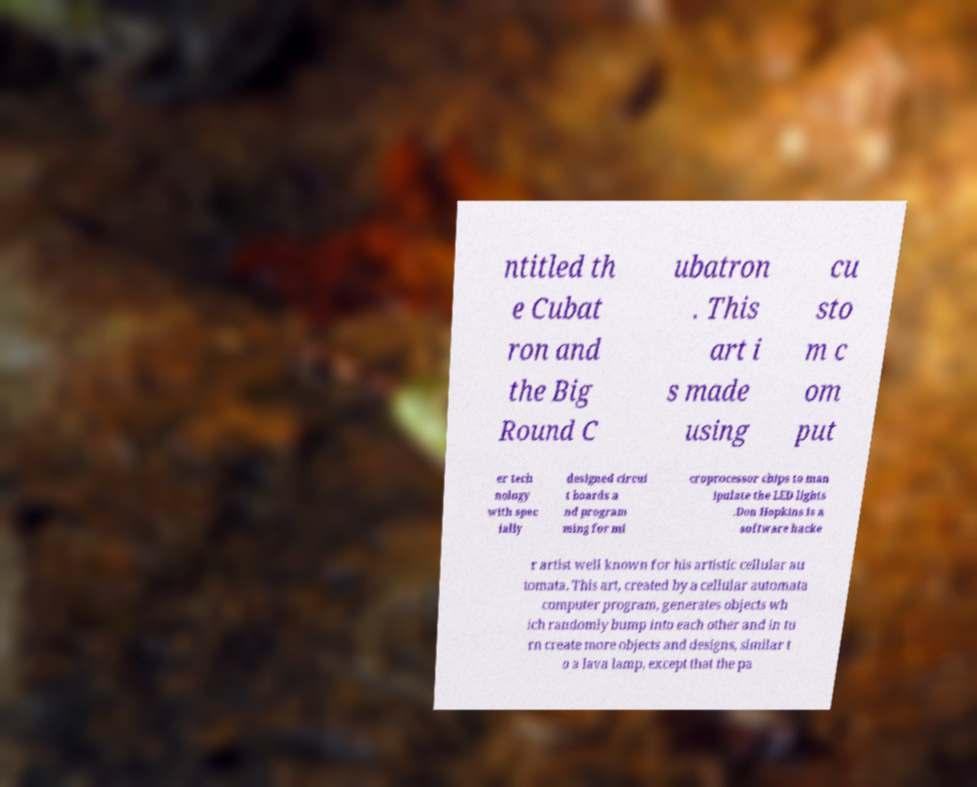Please read and relay the text visible in this image. What does it say? ntitled th e Cubat ron and the Big Round C ubatron . This art i s made using cu sto m c om put er tech nology with spec ially designed circui t boards a nd program ming for mi croprocessor chips to man ipulate the LED lights .Don Hopkins is a software hacke r artist well known for his artistic cellular au tomata. This art, created by a cellular automata computer program, generates objects wh ich randomly bump into each other and in tu rn create more objects and designs, similar t o a lava lamp, except that the pa 